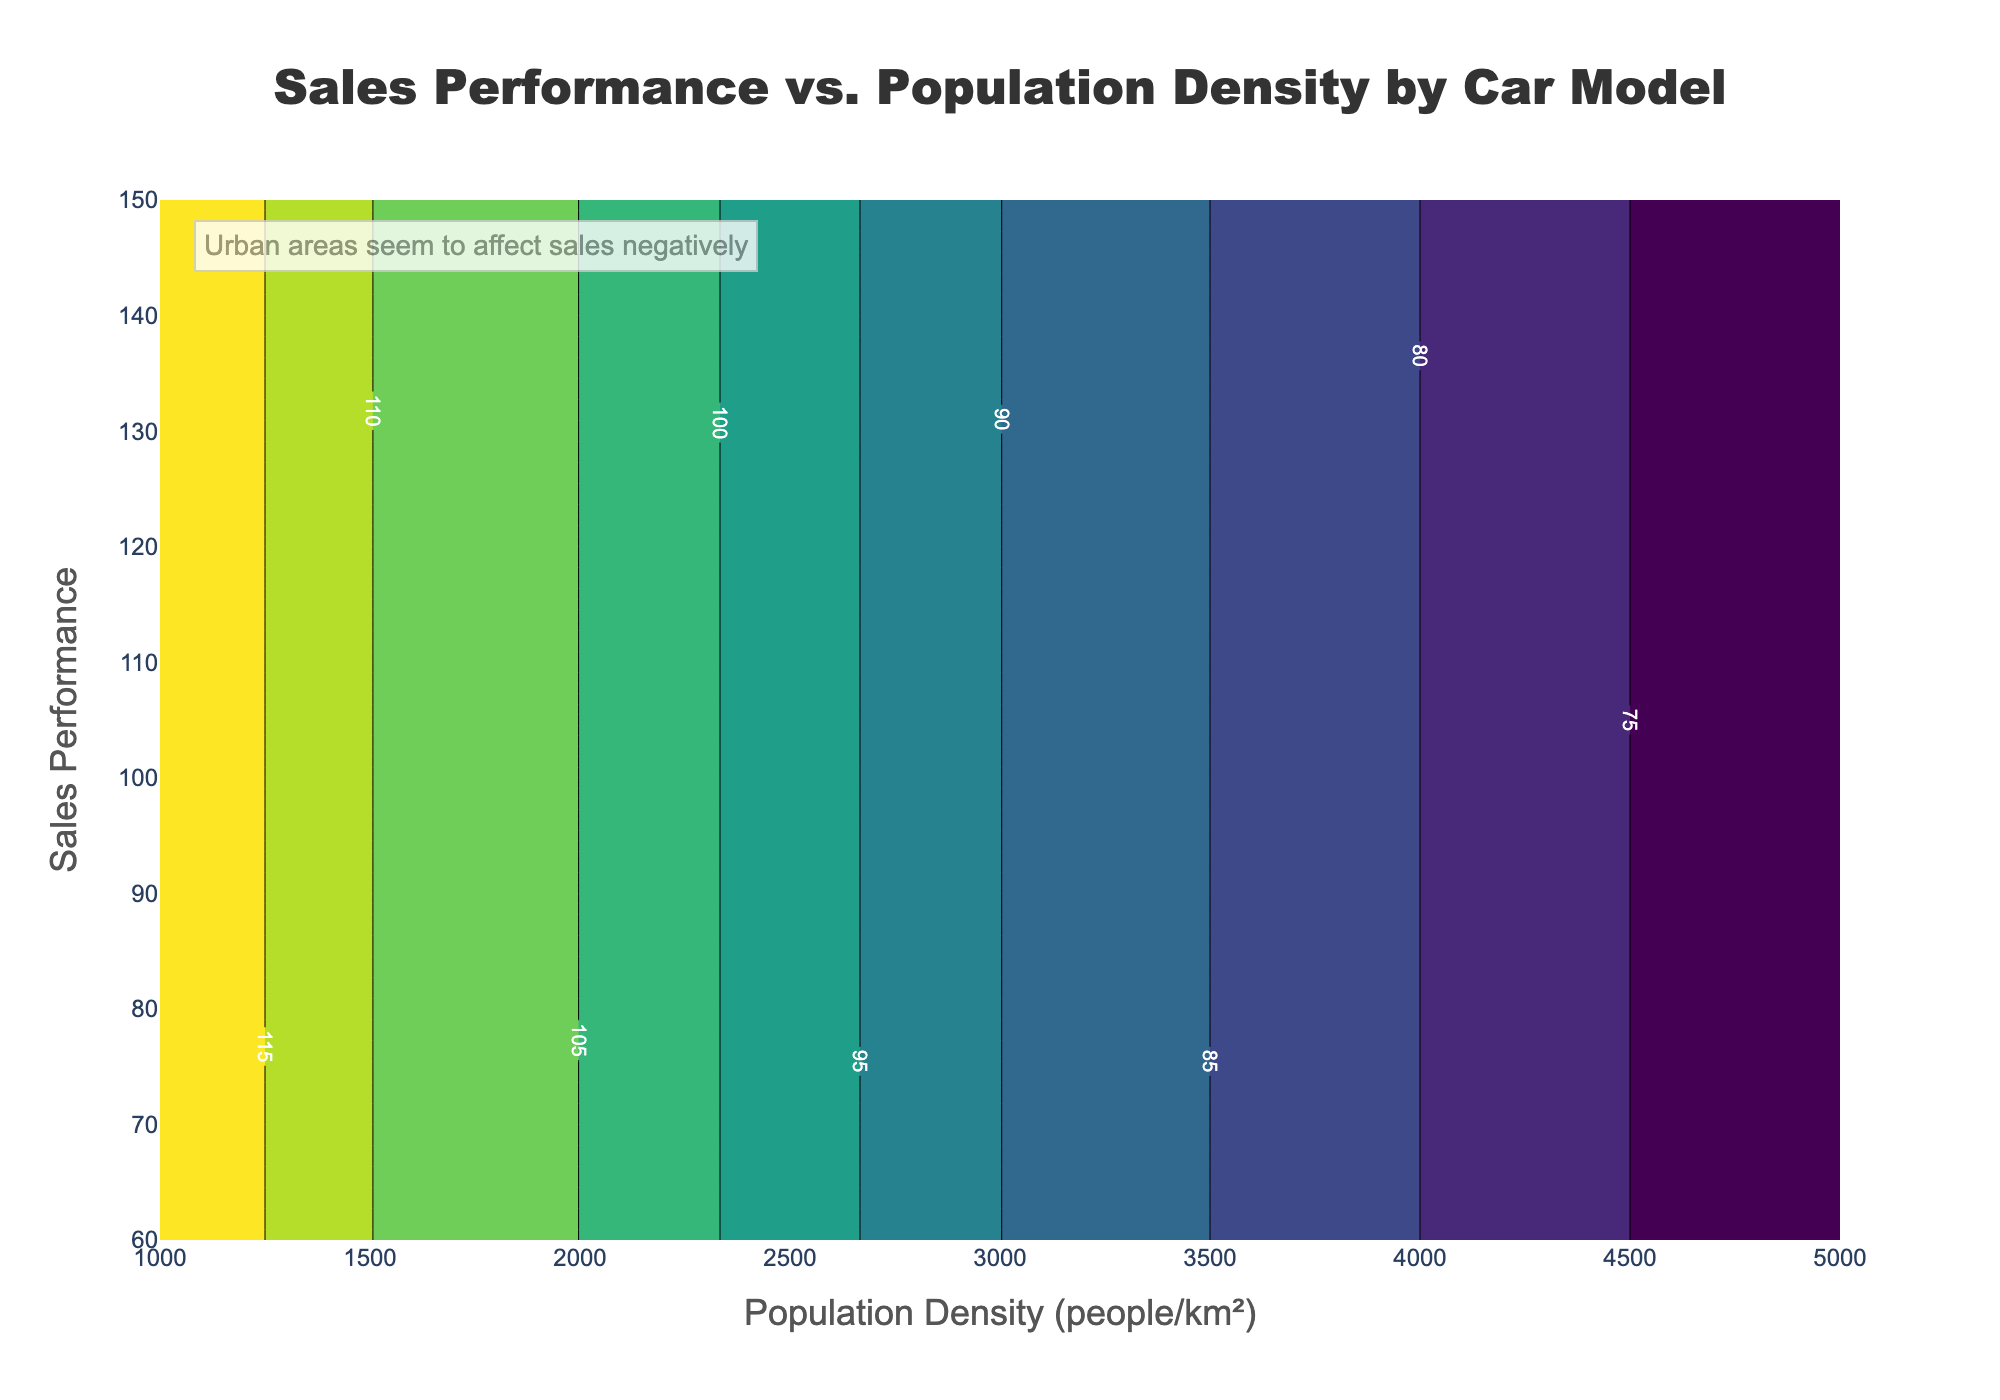What is the title of the plot? The title is usually placed at the top of the plot, indicating what the plot is about. In this case, the title is displayed prominently at the top.
Answer: Sales Performance vs. Population Density by Car Model What do the x and y axis titles represent on the plot? The titles of the x and y axes are typically located beside the respective axes. Here, these titles indicate what the axes represent.
Answer: Population Density (people/km²) and Sales Performance Which car model shows the highest sales performance at low population density? By examining the contour regions at the lower population density values on the x-axis, one can identify which model's contour reaches the highest on the y-axis.
Answer: Ford F-150 How does the sales performance trend change as population density increases for Toyota Camry? Follow the contour for Toyota Camry from low to high values on the x-axis, noting the shift in sales performance values on the y-axis.
Answer: Decreases For which population density range is the sales performance of all car models relatively close? By examining areas where different models' contours are closely packed together on the x-axis, one can deduce the population density range.
Answer: 4000 to 5000 people/km² What can be inferred about car sales performance in denser urban areas based on the annotation? The annotation provides an insight into how sales are affected by population density. Read the annotation directly.
Answer: Sales decline in dense urban areas What is the general color scheme used for the contours? The color gradient of the contours is visible and often follows a specific color scale pattern. Here, it is stated that 'Viridis' is used, which ranges from dark to light colors.
Answer: Viridis color scale Which car model maintains relatively higher sales at a population density of 3000 people/km²? Identify the population density of 3000 on the x-axis and observe which model's contour is highest on the y-axis at this point.
Answer: Ford F-150 Compare the sales performance trend of Honda Civic and Chevrolet Malibu as population density increases from 1000 to 3000 people/km². Track the contours of both Honda Civic and Chevrolet Malibu from 1000 to 3000 on the x-axis and note how their sales performance values change on the y-axis.
Answer: Honda Civic declines from 130 to 100, Chevrolet Malibu declines from 110 to 95 Which car models have their sales performance dropping below 100 the earliest as population density increases? Follow the contours to see where each model's performance crosses below the 100 mark on the y-axis as you move along the x-axis from left to right.
Answer: Toyota Camry and Chevrolet Malibu 